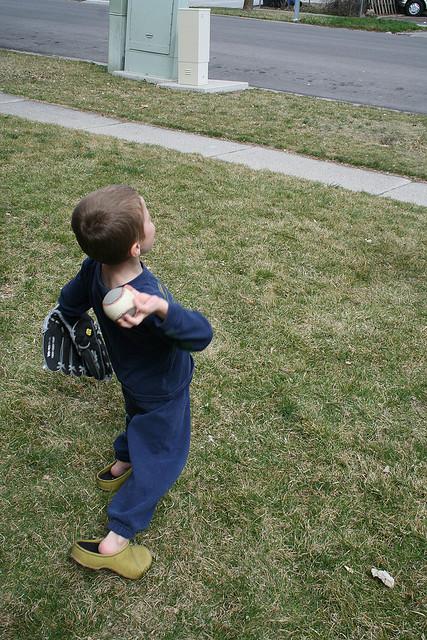Is the child wearing pants?
Be succinct. Yes. Is the kid barefoot?
Keep it brief. No. What is show on the child's glove?
Concise answer only. Logo. What is the boy's hair color?
Give a very brief answer. Brown. Is it sunny in the picture?
Keep it brief. No. What color is the stripe on the baseball?
Write a very short answer. Red. What is this kid waiting for?
Answer briefly. To throw ball. What did the kid just throw?
Give a very brief answer. Ball. What is the spherical object in the boy's hand?
Be succinct. Ball. What is the boy looking at?
Answer briefly. Street. How old is the young boy?
Short answer required. 4. What are they catching?
Be succinct. Baseball. 